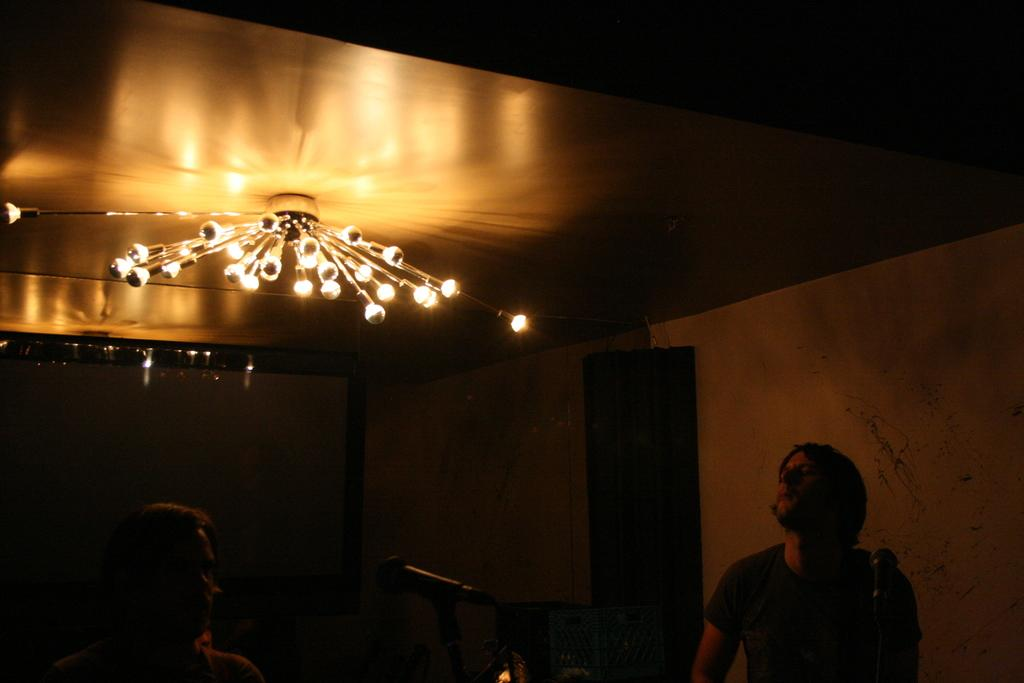Who or what can be seen in the image? There are people in the image. What objects are present that might be related to the people's activities? There are microphones (mics) in the image. What can be seen in the background of the image? There are lights and a wall visible in the background of the image. What type of farm animals can be seen grazing in the image? There is no farm or farm animals present in the image. What color is the silver cemetery gate in the image? There is no cemetery or silver gate present in the image. 